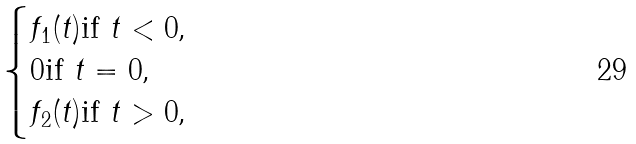Convert formula to latex. <formula><loc_0><loc_0><loc_500><loc_500>\begin{cases} f _ { 1 } ( t ) \text {if $t<0$,} \\ 0 \text {if $t=0$,} \\ f _ { 2 } ( t ) \text {if $t>0$,} \end{cases}</formula> 